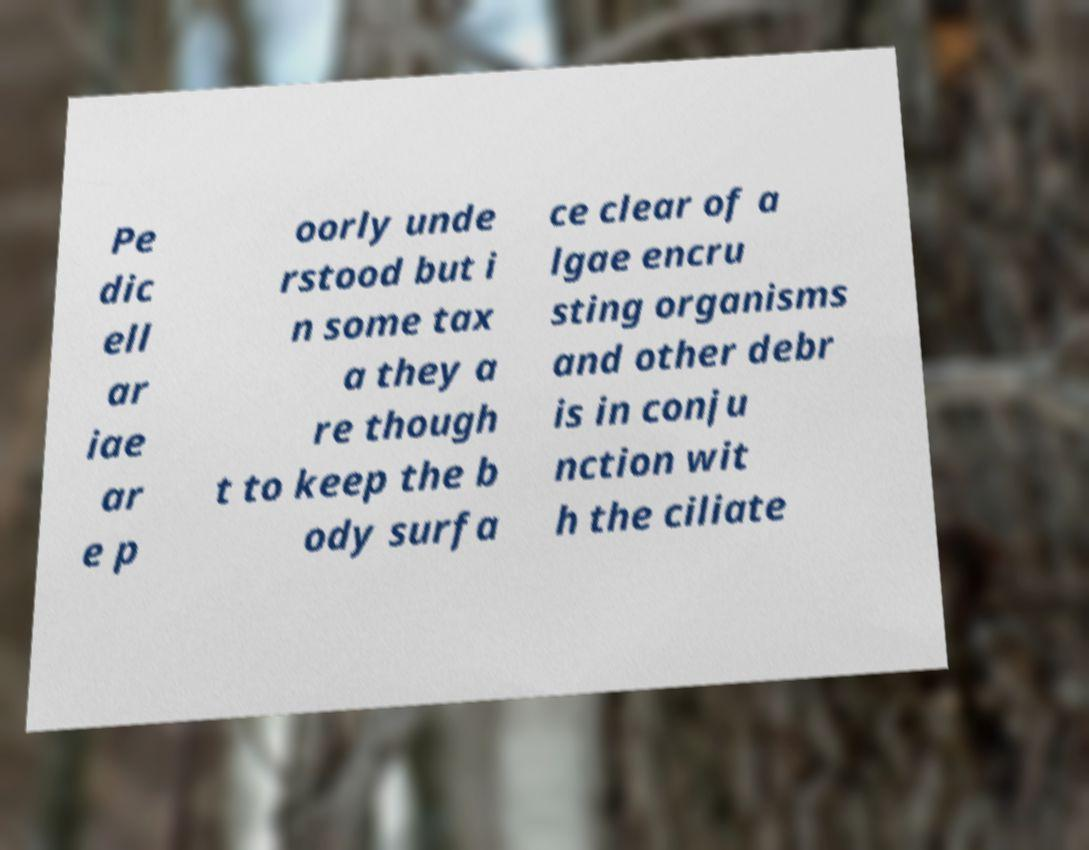For documentation purposes, I need the text within this image transcribed. Could you provide that? Pe dic ell ar iae ar e p oorly unde rstood but i n some tax a they a re though t to keep the b ody surfa ce clear of a lgae encru sting organisms and other debr is in conju nction wit h the ciliate 